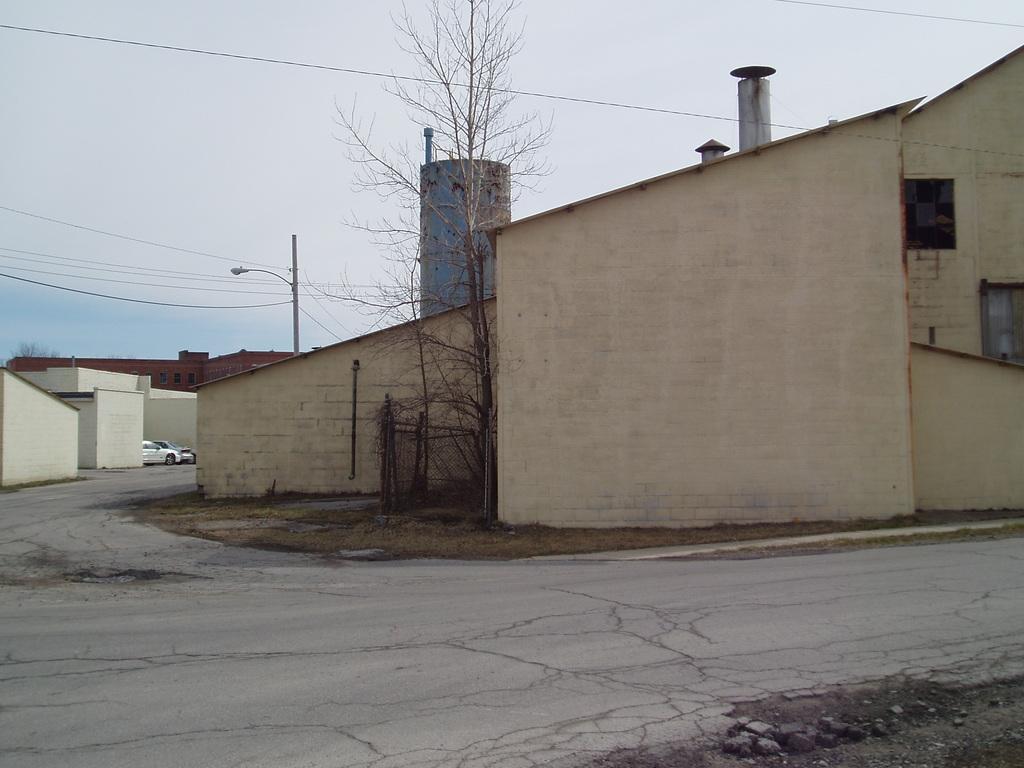Describe this image in one or two sentences. In the image we can see there are buildings, poles and electric wires. Here we can see the road, grass and tree branches. We can see there are vehicles and the sky. 